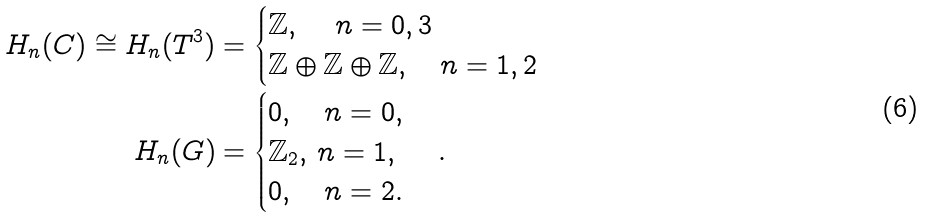<formula> <loc_0><loc_0><loc_500><loc_500>H _ { n } ( C ) \cong H _ { n } ( T ^ { 3 } ) & = \begin{cases} \mathbb { Z } , \quad \, n = 0 , 3 \\ \mathbb { Z } \oplus \mathbb { Z } \oplus \mathbb { Z } , \quad n = 1 , 2 \end{cases} \\ H _ { n } ( G ) & = \begin{cases} 0 , \quad n = 0 , \\ \mathbb { Z } _ { 2 } , \, n = 1 , \\ 0 , \quad n = 2 . \end{cases} .</formula> 